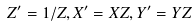<formula> <loc_0><loc_0><loc_500><loc_500>Z ^ { \prime } = 1 / Z , X ^ { \prime } = X Z , Y ^ { \prime } = Y Z</formula> 